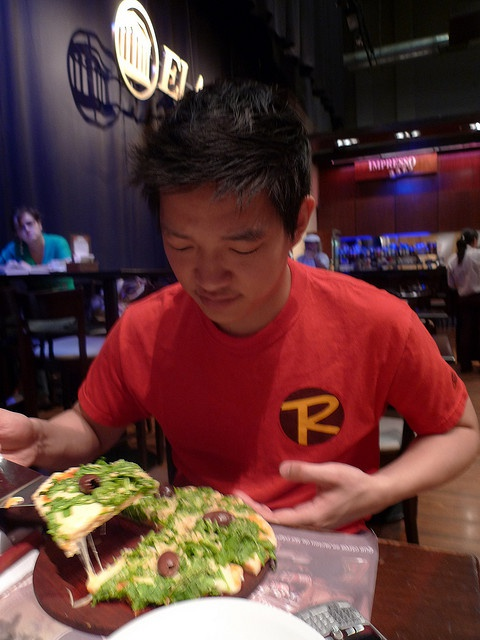Describe the objects in this image and their specific colors. I can see people in navy, maroon, brown, and black tones, dining table in navy, maroon, darkgray, white, and olive tones, pizza in navy, olive, and khaki tones, people in navy, black, blue, and purple tones, and chair in navy, black, gray, and purple tones in this image. 